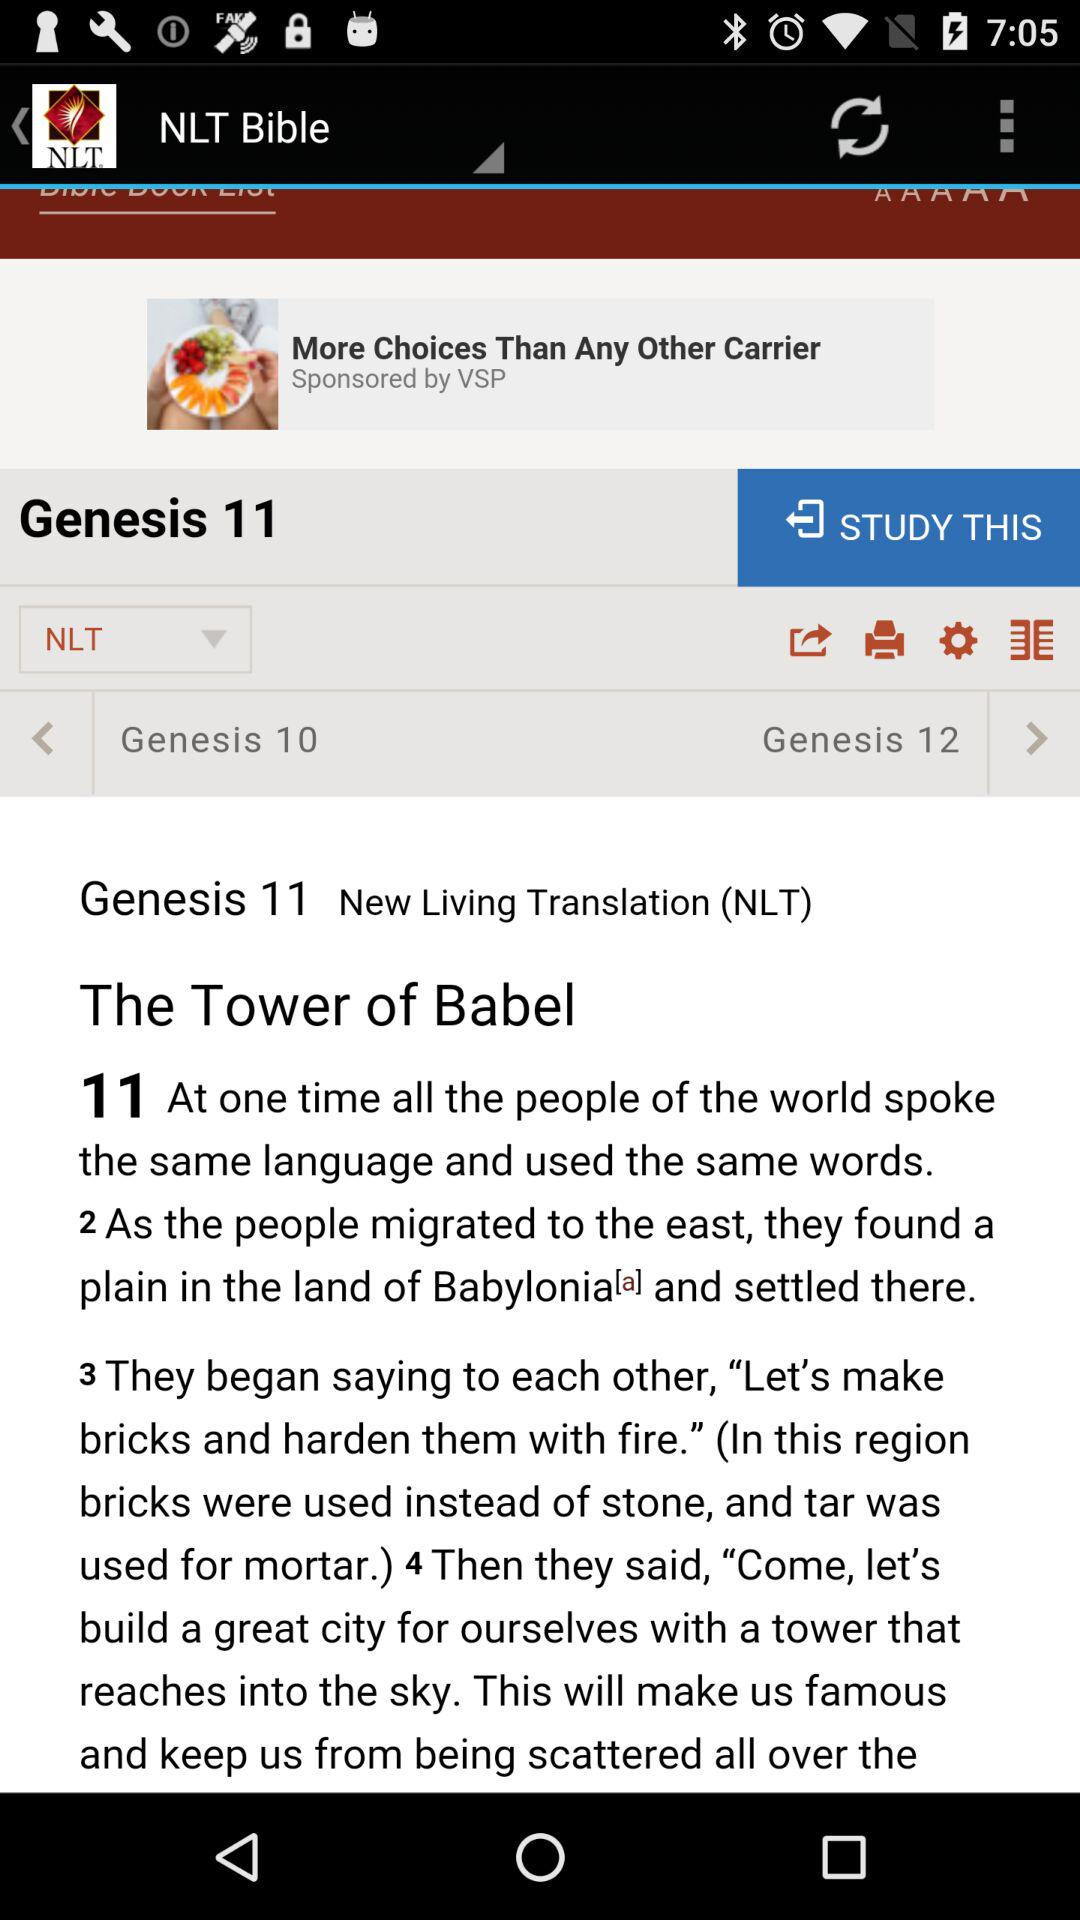Which chapter number of "Genesis" is currently open? The chapter number of "Genesis" that is currently open is 11. 